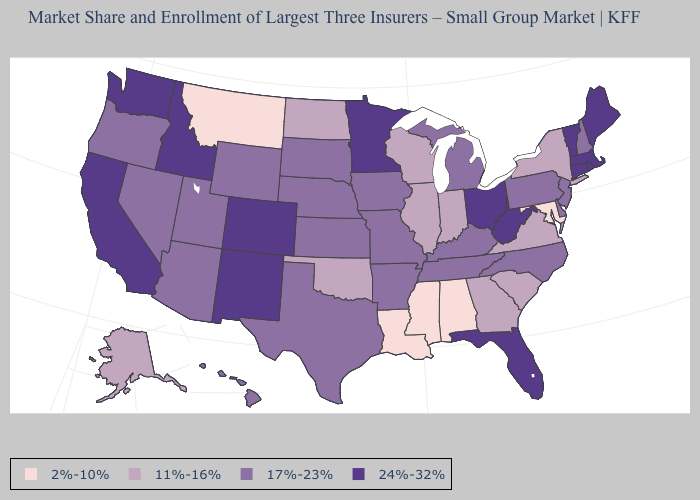What is the highest value in states that border Oregon?
Short answer required. 24%-32%. Name the states that have a value in the range 24%-32%?
Keep it brief. California, Colorado, Connecticut, Florida, Idaho, Maine, Massachusetts, Minnesota, New Mexico, Ohio, Rhode Island, Vermont, Washington, West Virginia. Is the legend a continuous bar?
Quick response, please. No. What is the value of Pennsylvania?
Give a very brief answer. 17%-23%. Does Texas have the lowest value in the USA?
Answer briefly. No. Name the states that have a value in the range 17%-23%?
Concise answer only. Arizona, Arkansas, Delaware, Hawaii, Iowa, Kansas, Kentucky, Michigan, Missouri, Nebraska, Nevada, New Hampshire, New Jersey, North Carolina, Oregon, Pennsylvania, South Dakota, Tennessee, Texas, Utah, Wyoming. Which states have the lowest value in the South?
Concise answer only. Alabama, Louisiana, Maryland, Mississippi. What is the value of Kentucky?
Quick response, please. 17%-23%. Does Alabama have the lowest value in the USA?
Write a very short answer. Yes. What is the value of Texas?
Quick response, please. 17%-23%. What is the highest value in the West ?
Give a very brief answer. 24%-32%. What is the value of Hawaii?
Give a very brief answer. 17%-23%. Name the states that have a value in the range 2%-10%?
Keep it brief. Alabama, Louisiana, Maryland, Mississippi, Montana. What is the value of New Hampshire?
Write a very short answer. 17%-23%. What is the value of Arkansas?
Answer briefly. 17%-23%. 